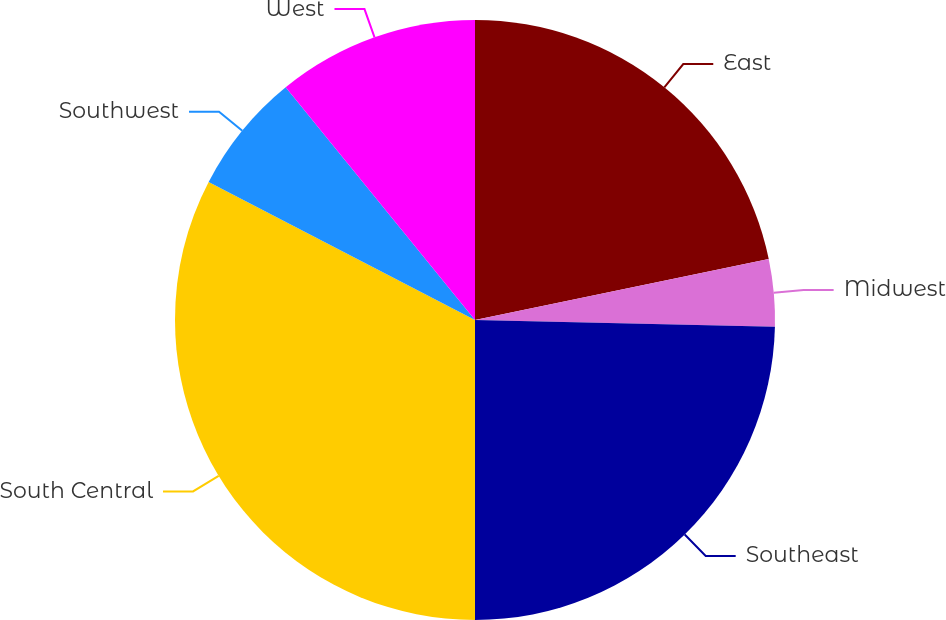<chart> <loc_0><loc_0><loc_500><loc_500><pie_chart><fcel>East<fcel>Midwest<fcel>Southeast<fcel>South Central<fcel>Southwest<fcel>West<nl><fcel>21.74%<fcel>3.62%<fcel>24.64%<fcel>32.61%<fcel>6.52%<fcel>10.87%<nl></chart> 